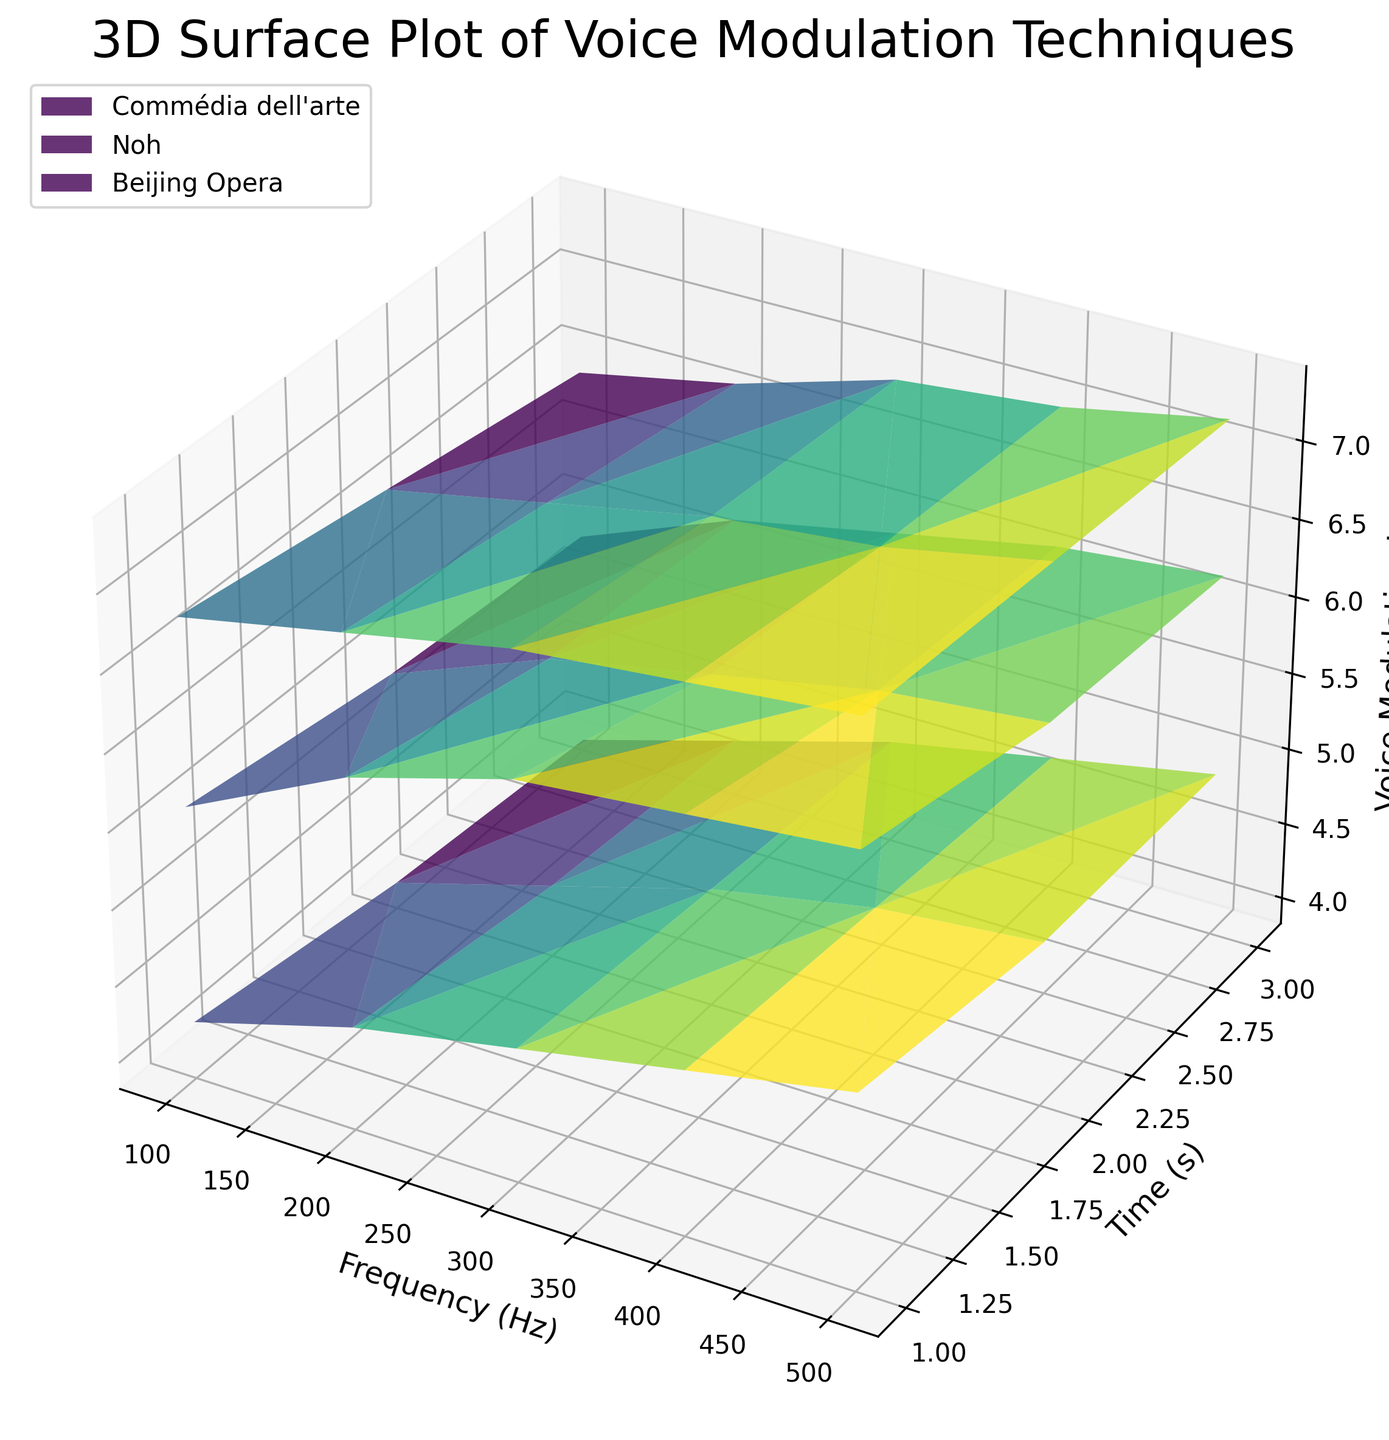Which traditional acting school shows the highest overall voice modulation level? By examining the heights and color intensity on the 3D surface plot, Beijing Opera exhibits the highest voice modulation levels overall.
Answer: Beijing Opera How does the voice modulation of Commédia dell'arte change over time at a frequency of 100 Hz? At 100 Hz, the voice modulation of Commédia dell'arte gradually decreases over time, observable through the reducing heights and less intense color of the corresponding surface plot.
Answer: Decreases Between Commédia dell'arte and Noh, which acting school shows a greater increase in voice modulation from 1 second to 2 seconds at 300 Hz? At 300 Hz, from 1 second to 2 seconds, Commédia dell'arte shows an increase from 6.4 to 6.0, amounting to a decrease. Noh shows an increase from 4.7 to 4.6, which also decreases, but Commédia dell'arte decreases more.
Answer: Noh What is the voice modulation level difference between Beijing Opera and Noh at 500 Hz and 3 seconds? At 500 Hz and 3 seconds, Beijing Opera's modulation level is 7.2 while Noh's is 4.9. The difference can be calculated as 7.2 - 4.9 = 2.3.
Answer: 2.3 Which acting school exhibits the least variation in voice modulation levels at a constant frequency over time? By examining the rapid color changes and height differences, Noh exhibits the least variation in voice modulation at any given frequency over time.
Answer: Noh For Commédia dell'arte, what is the average voice modulation level at 200 Hz over the 3 times measured? At 200 Hz for Commédia dell'arte, the modulation levels are 6.1, 5.8, and 5.7. The average is calculated as (6.1 + 5.8 + 5.7) / 3 = 5.8667.
Answer: 5.87 Comparing the modulation levels at 400 Hz and 2 seconds, which acting school leads, and by what margin? At 400 Hz and 2 seconds, Commédia dell'arte has a modulation level of 6.2, Noh has 4.8, and Beijing Opera has 7.1. Beijing Opera leads Commédia dell'arte by 7.1 - 6.2 = 0.9 and Noh by 7.1 - 4.8 = 2.3.
Answer: Beijing Opera by 2.3 